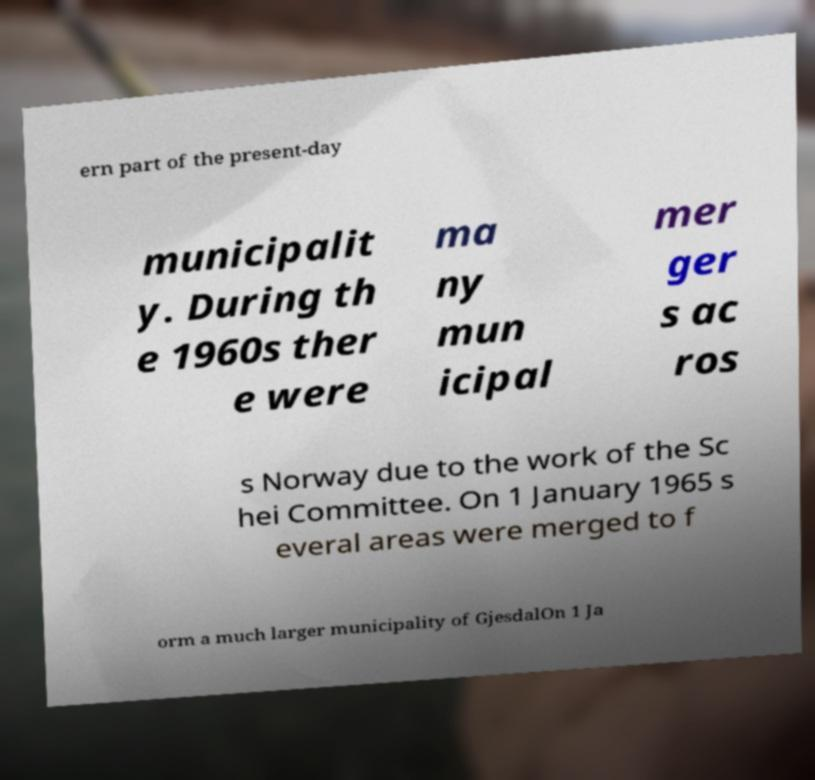For documentation purposes, I need the text within this image transcribed. Could you provide that? ern part of the present-day municipalit y. During th e 1960s ther e were ma ny mun icipal mer ger s ac ros s Norway due to the work of the Sc hei Committee. On 1 January 1965 s everal areas were merged to f orm a much larger municipality of GjesdalOn 1 Ja 